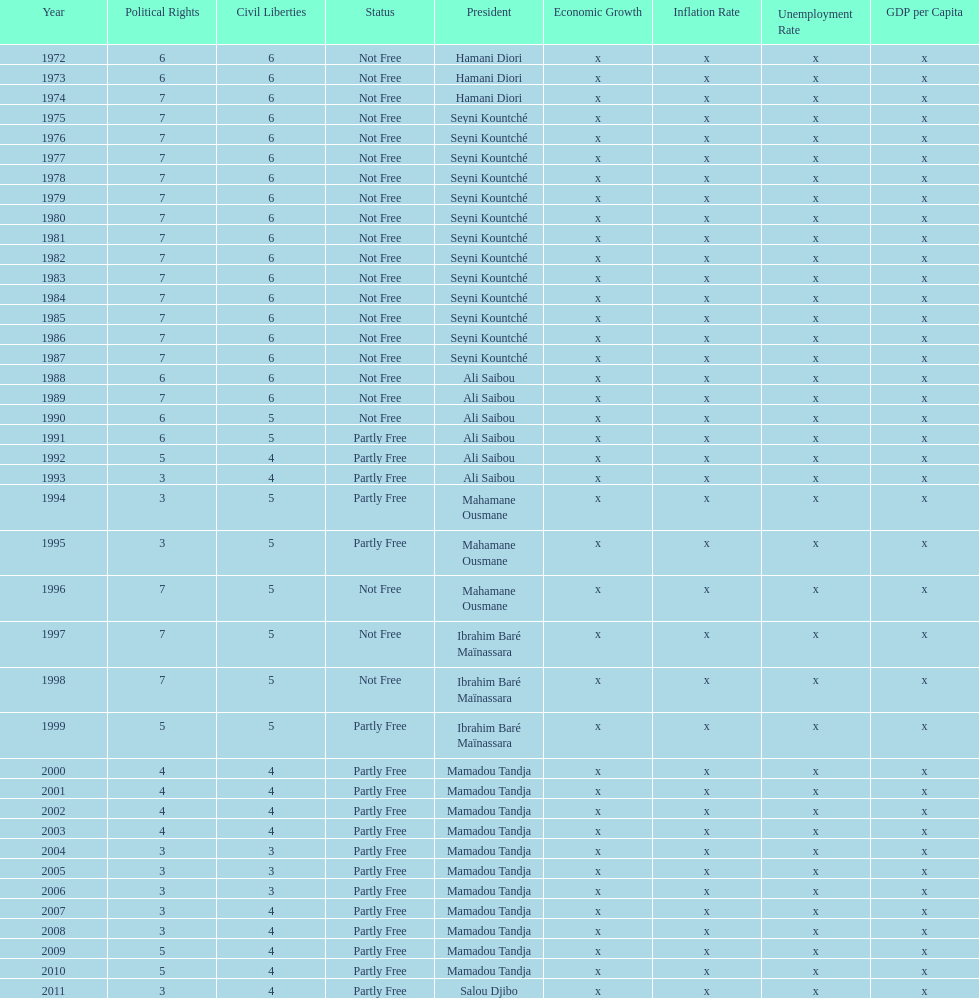What is the number of time seyni kountche has been president? 13. 